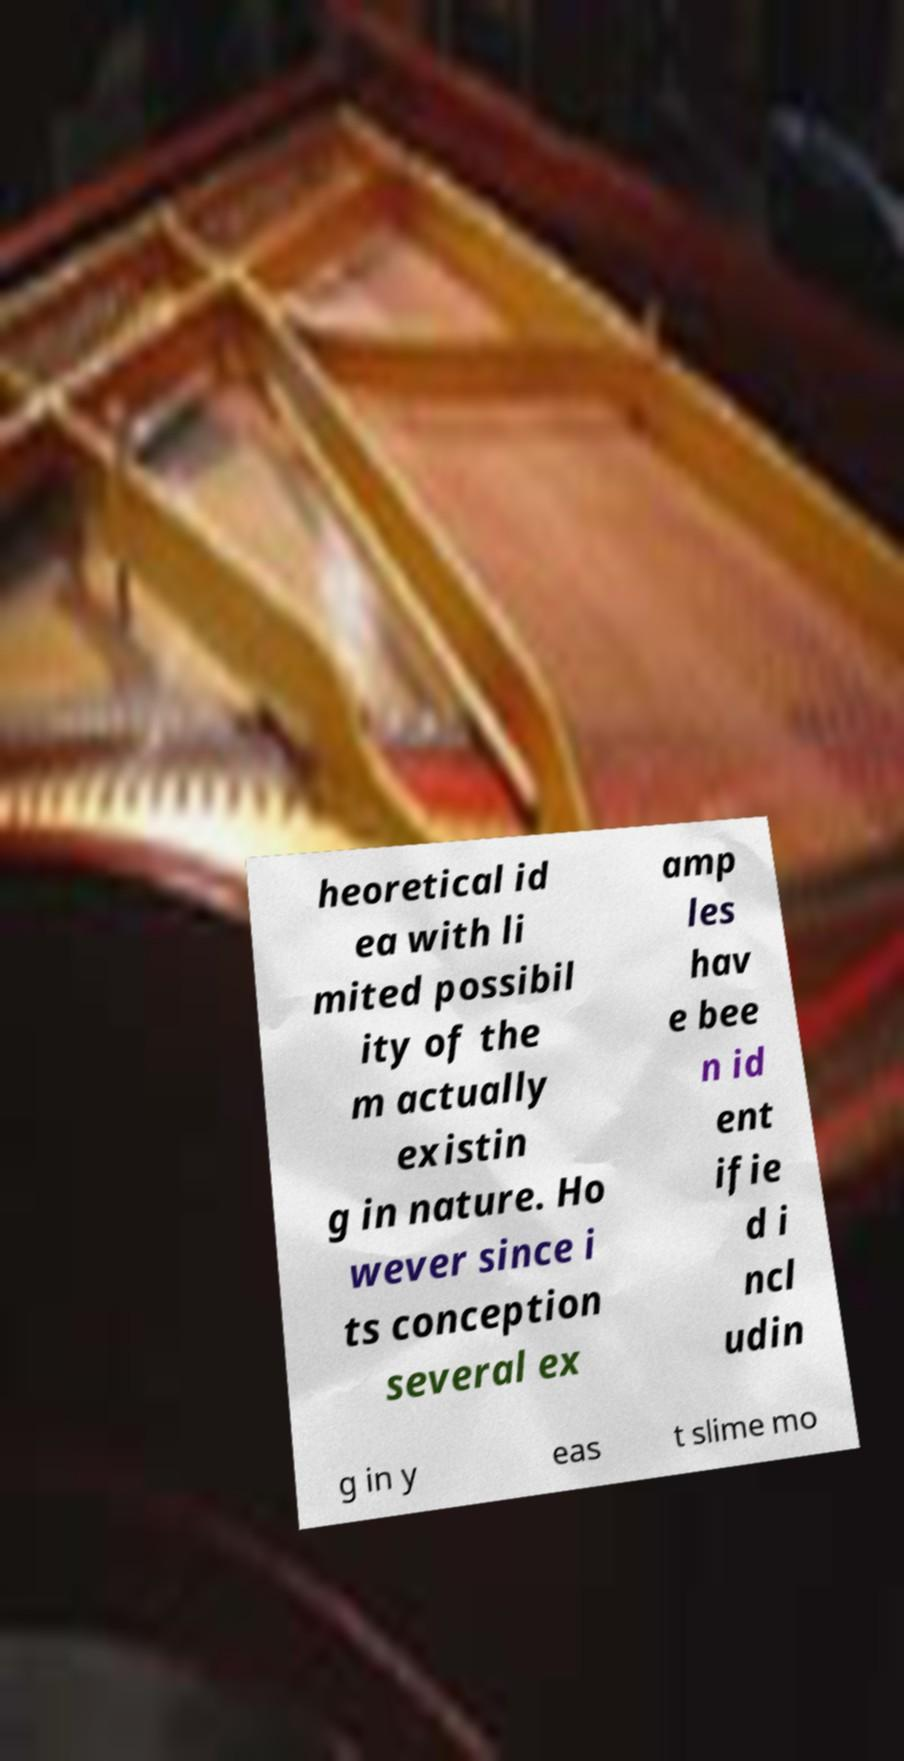Please read and relay the text visible in this image. What does it say? heoretical id ea with li mited possibil ity of the m actually existin g in nature. Ho wever since i ts conception several ex amp les hav e bee n id ent ifie d i ncl udin g in y eas t slime mo 